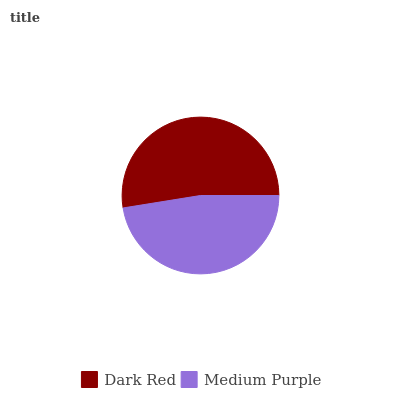Is Medium Purple the minimum?
Answer yes or no. Yes. Is Dark Red the maximum?
Answer yes or no. Yes. Is Medium Purple the maximum?
Answer yes or no. No. Is Dark Red greater than Medium Purple?
Answer yes or no. Yes. Is Medium Purple less than Dark Red?
Answer yes or no. Yes. Is Medium Purple greater than Dark Red?
Answer yes or no. No. Is Dark Red less than Medium Purple?
Answer yes or no. No. Is Dark Red the high median?
Answer yes or no. Yes. Is Medium Purple the low median?
Answer yes or no. Yes. Is Medium Purple the high median?
Answer yes or no. No. Is Dark Red the low median?
Answer yes or no. No. 